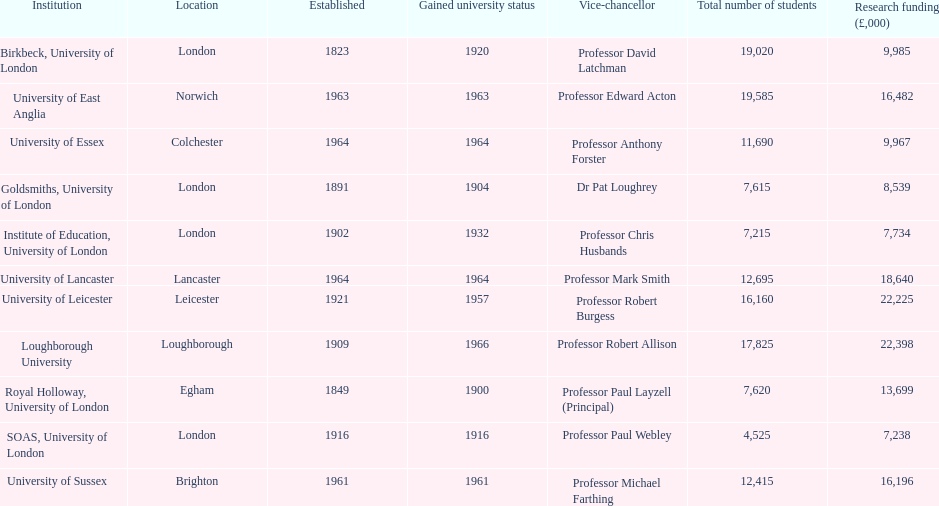What are the entities in the 1994 group? Birkbeck, University of London, University of East Anglia, University of Essex, Goldsmiths, University of London, Institute of Education, University of London, University of Lancaster, University of Leicester, Loughborough University, Royal Holloway, University of London, SOAS, University of London, University of Sussex. Write the full table. {'header': ['Institution', 'Location', 'Established', 'Gained university status', 'Vice-chancellor', 'Total number of students', 'Research funding (£,000)'], 'rows': [['Birkbeck, University of London', 'London', '1823', '1920', 'Professor David Latchman', '19,020', '9,985'], ['University of East Anglia', 'Norwich', '1963', '1963', 'Professor Edward Acton', '19,585', '16,482'], ['University of Essex', 'Colchester', '1964', '1964', 'Professor Anthony Forster', '11,690', '9,967'], ['Goldsmiths, University of London', 'London', '1891', '1904', 'Dr Pat Loughrey', '7,615', '8,539'], ['Institute of Education, University of London', 'London', '1902', '1932', 'Professor Chris Husbands', '7,215', '7,734'], ['University of Lancaster', 'Lancaster', '1964', '1964', 'Professor Mark Smith', '12,695', '18,640'], ['University of Leicester', 'Leicester', '1921', '1957', 'Professor Robert Burgess', '16,160', '22,225'], ['Loughborough University', 'Loughborough', '1909', '1966', 'Professor Robert Allison', '17,825', '22,398'], ['Royal Holloway, University of London', 'Egham', '1849', '1900', 'Professor Paul Layzell (Principal)', '7,620', '13,699'], ['SOAS, University of London', 'London', '1916', '1916', 'Professor Paul Webley', '4,525', '7,238'], ['University of Sussex', 'Brighton', '1961', '1961', 'Professor Michael Farthing', '12,415', '16,196']]} Which of these was transformed into a university most recently? Loughborough University. 